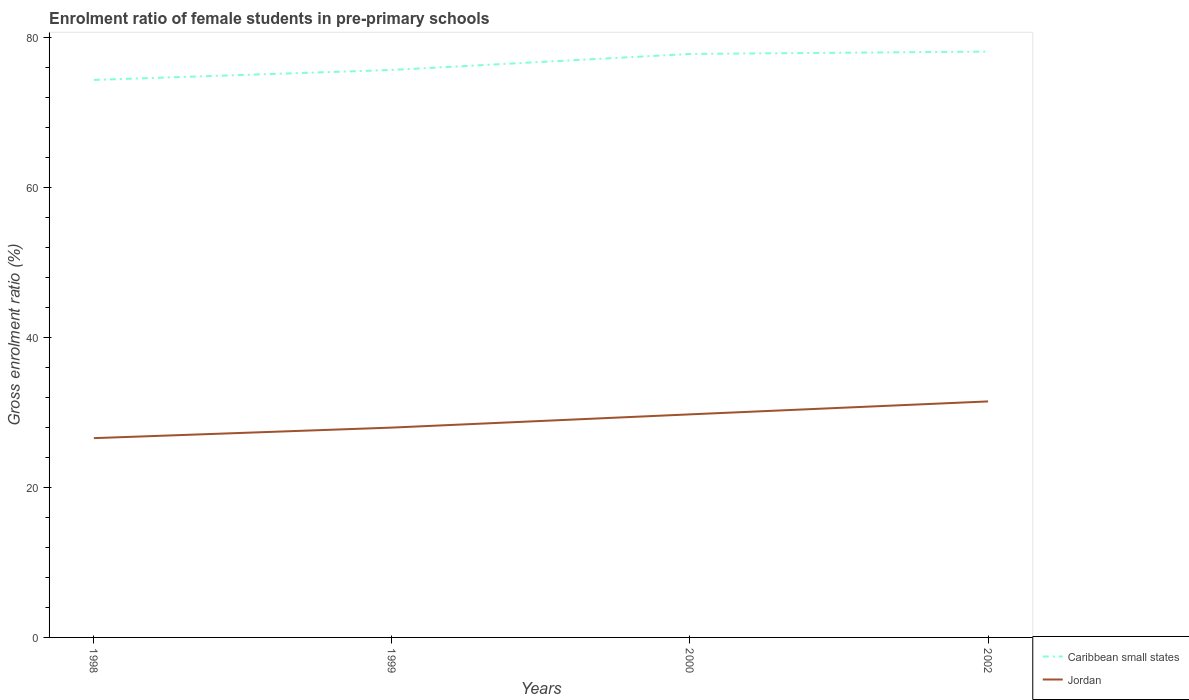Is the number of lines equal to the number of legend labels?
Your answer should be very brief. Yes. Across all years, what is the maximum enrolment ratio of female students in pre-primary schools in Caribbean small states?
Provide a succinct answer. 74.3. What is the total enrolment ratio of female students in pre-primary schools in Caribbean small states in the graph?
Offer a very short reply. -1.33. What is the difference between the highest and the second highest enrolment ratio of female students in pre-primary schools in Jordan?
Your answer should be compact. 4.89. What is the difference between the highest and the lowest enrolment ratio of female students in pre-primary schools in Jordan?
Keep it short and to the point. 2. How many lines are there?
Your answer should be compact. 2. How many years are there in the graph?
Offer a very short reply. 4. What is the difference between two consecutive major ticks on the Y-axis?
Provide a short and direct response. 20. Does the graph contain grids?
Your answer should be compact. No. Where does the legend appear in the graph?
Give a very brief answer. Bottom right. How are the legend labels stacked?
Offer a terse response. Vertical. What is the title of the graph?
Provide a succinct answer. Enrolment ratio of female students in pre-primary schools. Does "Mozambique" appear as one of the legend labels in the graph?
Your answer should be compact. No. What is the label or title of the Y-axis?
Ensure brevity in your answer.  Gross enrolment ratio (%). What is the Gross enrolment ratio (%) in Caribbean small states in 1998?
Your answer should be compact. 74.3. What is the Gross enrolment ratio (%) of Jordan in 1998?
Your response must be concise. 26.56. What is the Gross enrolment ratio (%) in Caribbean small states in 1999?
Your answer should be compact. 75.63. What is the Gross enrolment ratio (%) in Jordan in 1999?
Provide a short and direct response. 27.96. What is the Gross enrolment ratio (%) of Caribbean small states in 2000?
Your response must be concise. 77.76. What is the Gross enrolment ratio (%) in Jordan in 2000?
Give a very brief answer. 29.73. What is the Gross enrolment ratio (%) in Caribbean small states in 2002?
Ensure brevity in your answer.  78.08. What is the Gross enrolment ratio (%) of Jordan in 2002?
Offer a terse response. 31.45. Across all years, what is the maximum Gross enrolment ratio (%) in Caribbean small states?
Offer a terse response. 78.08. Across all years, what is the maximum Gross enrolment ratio (%) in Jordan?
Your answer should be very brief. 31.45. Across all years, what is the minimum Gross enrolment ratio (%) in Caribbean small states?
Provide a short and direct response. 74.3. Across all years, what is the minimum Gross enrolment ratio (%) in Jordan?
Ensure brevity in your answer.  26.56. What is the total Gross enrolment ratio (%) of Caribbean small states in the graph?
Give a very brief answer. 305.76. What is the total Gross enrolment ratio (%) in Jordan in the graph?
Offer a terse response. 115.7. What is the difference between the Gross enrolment ratio (%) of Caribbean small states in 1998 and that in 1999?
Your response must be concise. -1.33. What is the difference between the Gross enrolment ratio (%) of Jordan in 1998 and that in 1999?
Keep it short and to the point. -1.41. What is the difference between the Gross enrolment ratio (%) of Caribbean small states in 1998 and that in 2000?
Offer a terse response. -3.46. What is the difference between the Gross enrolment ratio (%) of Jordan in 1998 and that in 2000?
Make the answer very short. -3.17. What is the difference between the Gross enrolment ratio (%) of Caribbean small states in 1998 and that in 2002?
Make the answer very short. -3.78. What is the difference between the Gross enrolment ratio (%) in Jordan in 1998 and that in 2002?
Keep it short and to the point. -4.89. What is the difference between the Gross enrolment ratio (%) of Caribbean small states in 1999 and that in 2000?
Offer a very short reply. -2.13. What is the difference between the Gross enrolment ratio (%) in Jordan in 1999 and that in 2000?
Keep it short and to the point. -1.76. What is the difference between the Gross enrolment ratio (%) of Caribbean small states in 1999 and that in 2002?
Give a very brief answer. -2.45. What is the difference between the Gross enrolment ratio (%) of Jordan in 1999 and that in 2002?
Ensure brevity in your answer.  -3.49. What is the difference between the Gross enrolment ratio (%) in Caribbean small states in 2000 and that in 2002?
Your answer should be very brief. -0.32. What is the difference between the Gross enrolment ratio (%) of Jordan in 2000 and that in 2002?
Your response must be concise. -1.72. What is the difference between the Gross enrolment ratio (%) in Caribbean small states in 1998 and the Gross enrolment ratio (%) in Jordan in 1999?
Make the answer very short. 46.33. What is the difference between the Gross enrolment ratio (%) of Caribbean small states in 1998 and the Gross enrolment ratio (%) of Jordan in 2000?
Your answer should be compact. 44.57. What is the difference between the Gross enrolment ratio (%) in Caribbean small states in 1998 and the Gross enrolment ratio (%) in Jordan in 2002?
Your answer should be compact. 42.85. What is the difference between the Gross enrolment ratio (%) of Caribbean small states in 1999 and the Gross enrolment ratio (%) of Jordan in 2000?
Give a very brief answer. 45.9. What is the difference between the Gross enrolment ratio (%) of Caribbean small states in 1999 and the Gross enrolment ratio (%) of Jordan in 2002?
Your response must be concise. 44.18. What is the difference between the Gross enrolment ratio (%) in Caribbean small states in 2000 and the Gross enrolment ratio (%) in Jordan in 2002?
Make the answer very short. 46.31. What is the average Gross enrolment ratio (%) in Caribbean small states per year?
Give a very brief answer. 76.44. What is the average Gross enrolment ratio (%) in Jordan per year?
Keep it short and to the point. 28.93. In the year 1998, what is the difference between the Gross enrolment ratio (%) in Caribbean small states and Gross enrolment ratio (%) in Jordan?
Ensure brevity in your answer.  47.74. In the year 1999, what is the difference between the Gross enrolment ratio (%) of Caribbean small states and Gross enrolment ratio (%) of Jordan?
Provide a succinct answer. 47.66. In the year 2000, what is the difference between the Gross enrolment ratio (%) of Caribbean small states and Gross enrolment ratio (%) of Jordan?
Ensure brevity in your answer.  48.03. In the year 2002, what is the difference between the Gross enrolment ratio (%) of Caribbean small states and Gross enrolment ratio (%) of Jordan?
Your answer should be compact. 46.62. What is the ratio of the Gross enrolment ratio (%) of Caribbean small states in 1998 to that in 1999?
Provide a succinct answer. 0.98. What is the ratio of the Gross enrolment ratio (%) of Jordan in 1998 to that in 1999?
Your answer should be compact. 0.95. What is the ratio of the Gross enrolment ratio (%) of Caribbean small states in 1998 to that in 2000?
Your answer should be very brief. 0.96. What is the ratio of the Gross enrolment ratio (%) of Jordan in 1998 to that in 2000?
Your response must be concise. 0.89. What is the ratio of the Gross enrolment ratio (%) of Caribbean small states in 1998 to that in 2002?
Your response must be concise. 0.95. What is the ratio of the Gross enrolment ratio (%) in Jordan in 1998 to that in 2002?
Your answer should be compact. 0.84. What is the ratio of the Gross enrolment ratio (%) in Caribbean small states in 1999 to that in 2000?
Make the answer very short. 0.97. What is the ratio of the Gross enrolment ratio (%) of Jordan in 1999 to that in 2000?
Ensure brevity in your answer.  0.94. What is the ratio of the Gross enrolment ratio (%) of Caribbean small states in 1999 to that in 2002?
Keep it short and to the point. 0.97. What is the ratio of the Gross enrolment ratio (%) in Jordan in 1999 to that in 2002?
Keep it short and to the point. 0.89. What is the ratio of the Gross enrolment ratio (%) of Jordan in 2000 to that in 2002?
Make the answer very short. 0.95. What is the difference between the highest and the second highest Gross enrolment ratio (%) of Caribbean small states?
Make the answer very short. 0.32. What is the difference between the highest and the second highest Gross enrolment ratio (%) of Jordan?
Make the answer very short. 1.72. What is the difference between the highest and the lowest Gross enrolment ratio (%) in Caribbean small states?
Keep it short and to the point. 3.78. What is the difference between the highest and the lowest Gross enrolment ratio (%) of Jordan?
Provide a succinct answer. 4.89. 